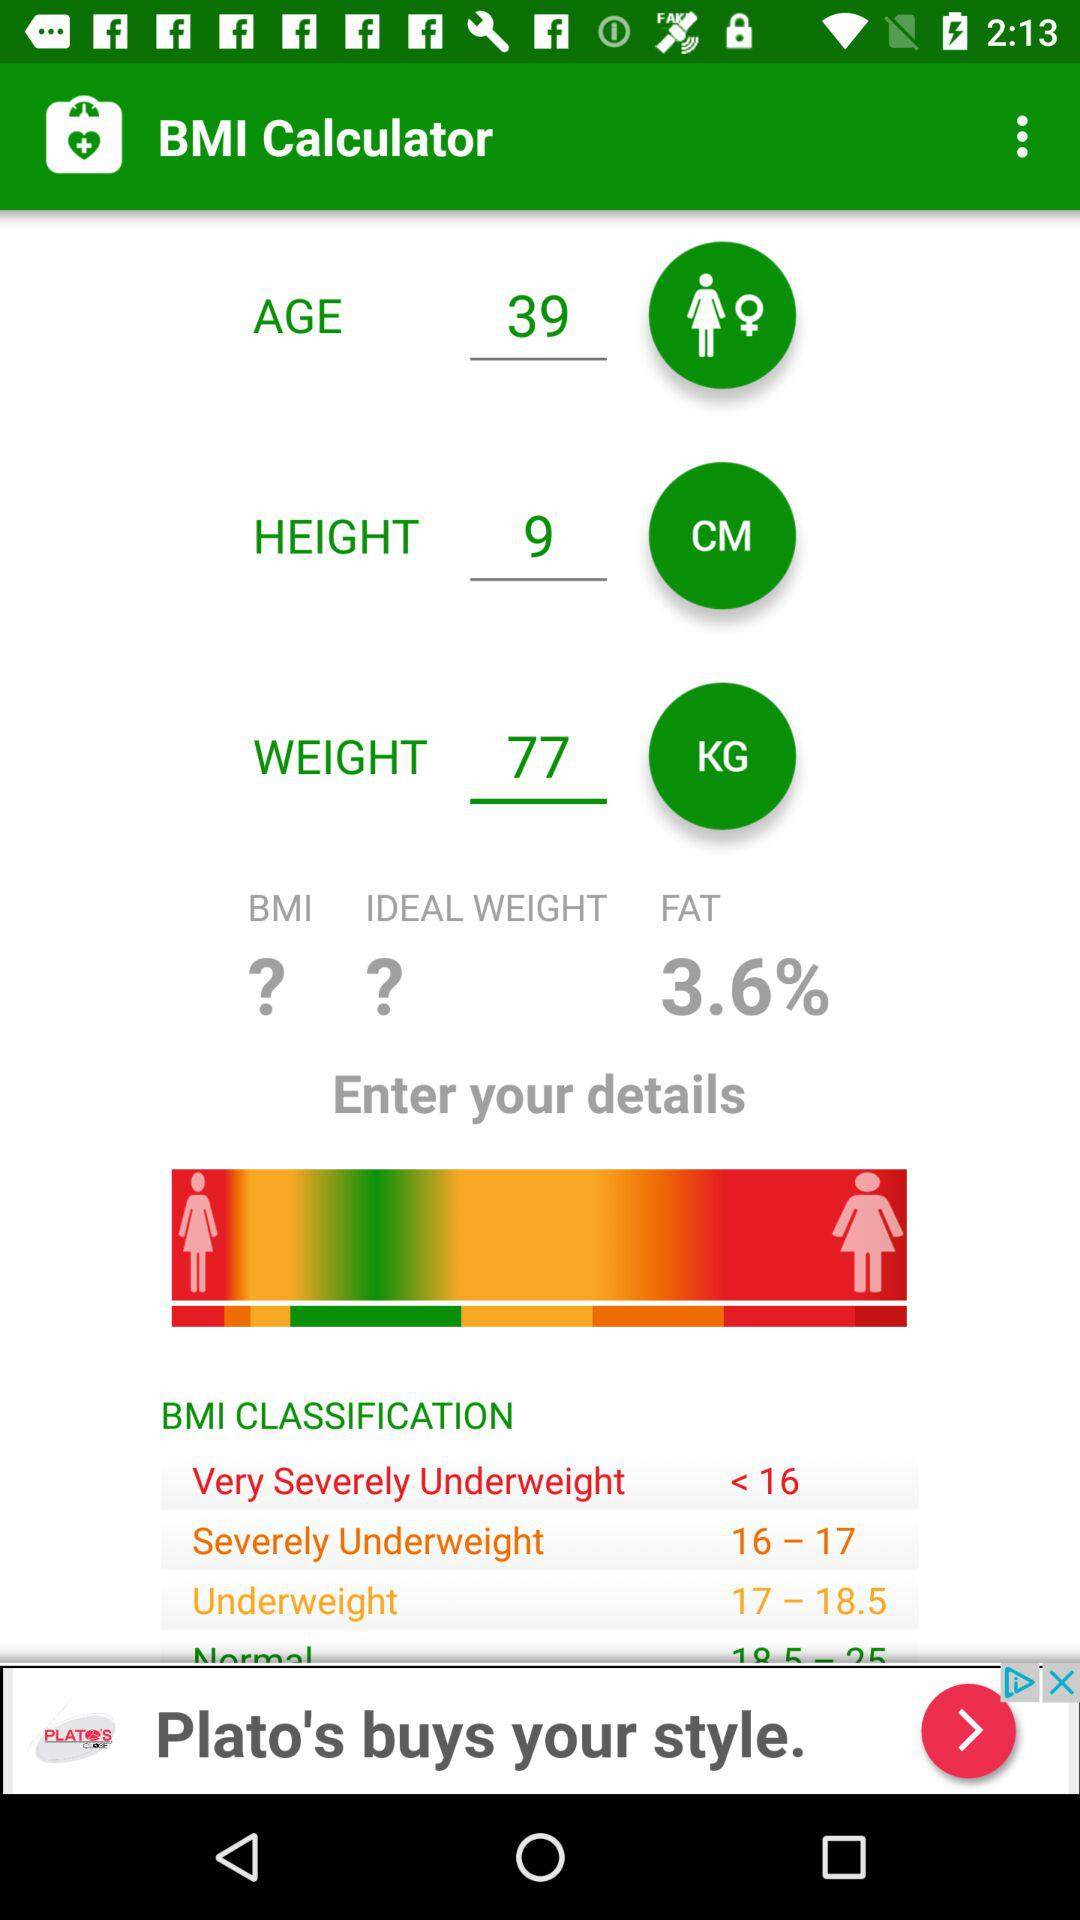What is the height? The height is 9 centimeters. 